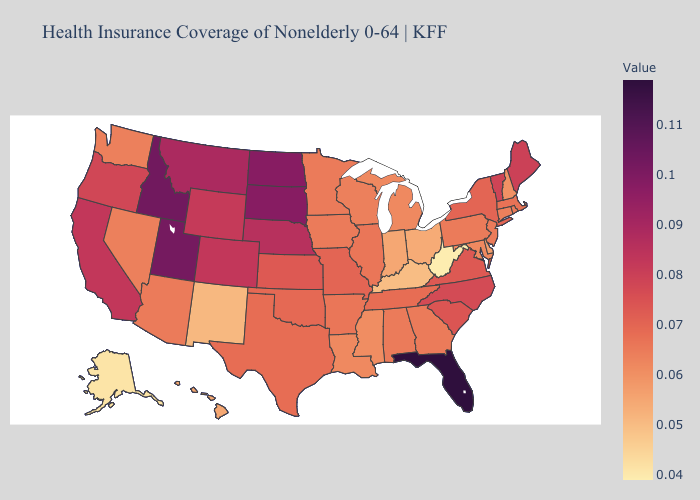Does Maine have the highest value in the Northeast?
Give a very brief answer. Yes. Does Tennessee have the highest value in the USA?
Keep it brief. No. Among the states that border Georgia , does Florida have the highest value?
Concise answer only. Yes. Among the states that border Tennessee , does North Carolina have the highest value?
Short answer required. Yes. Which states hav the highest value in the West?
Keep it brief. Idaho. 